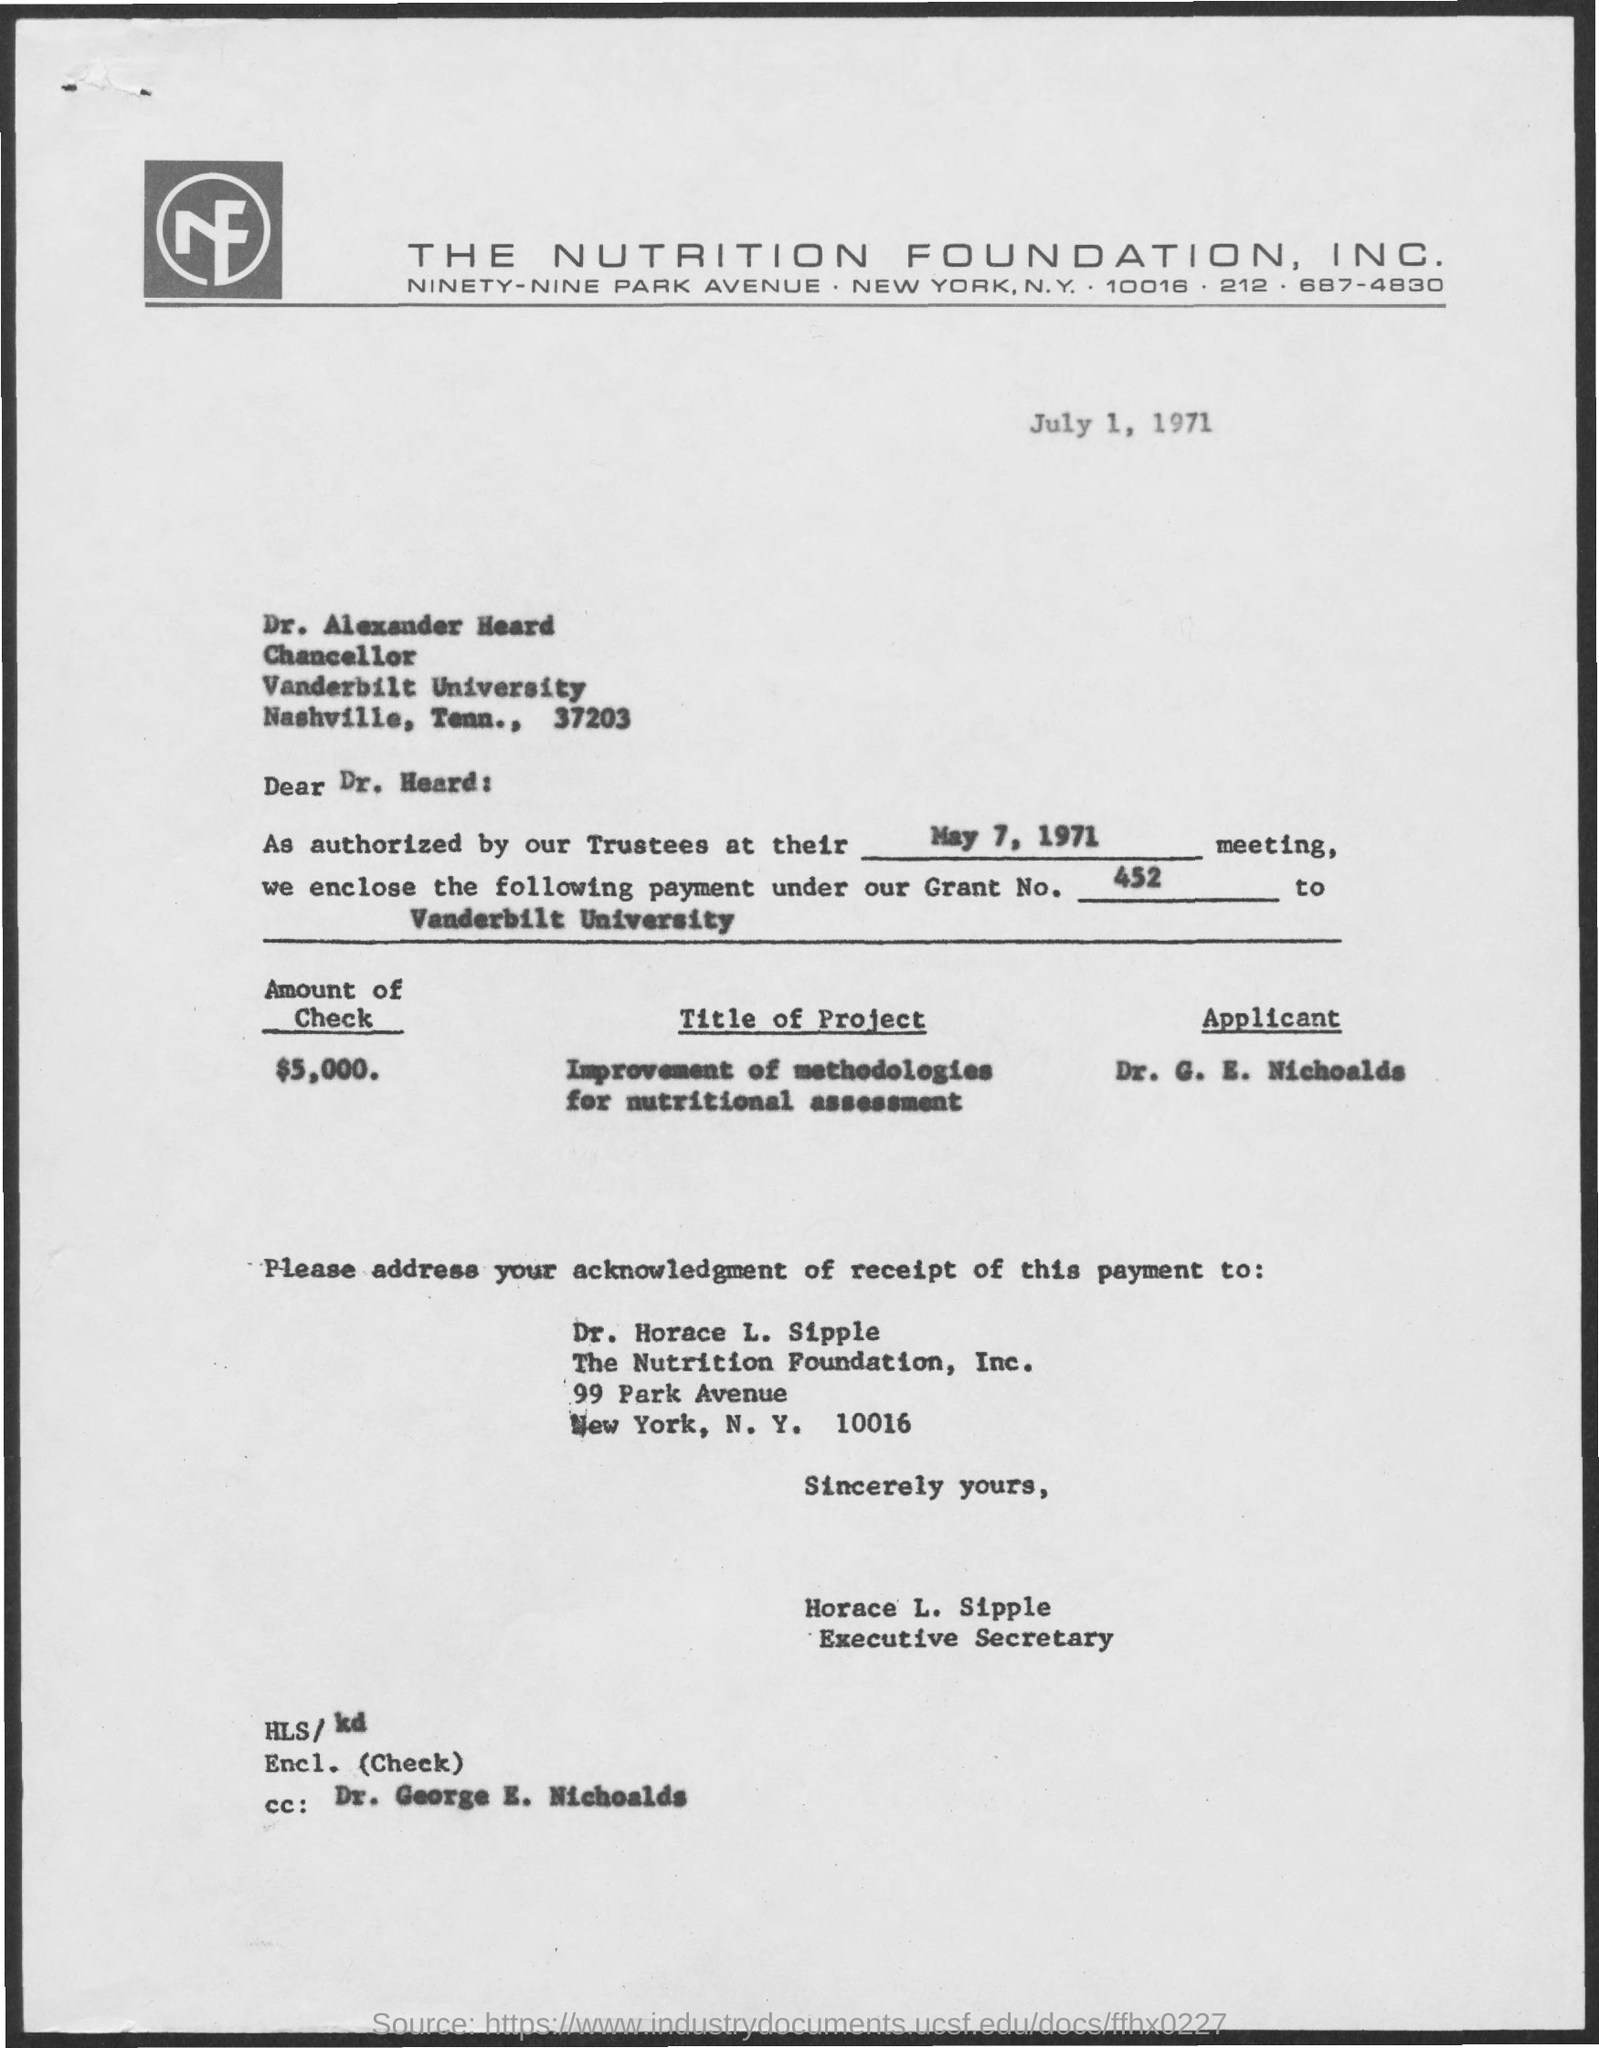Identify some key points in this picture. The amount mentioned in this document is $5,000. The document was issued on July 1, 1971. 